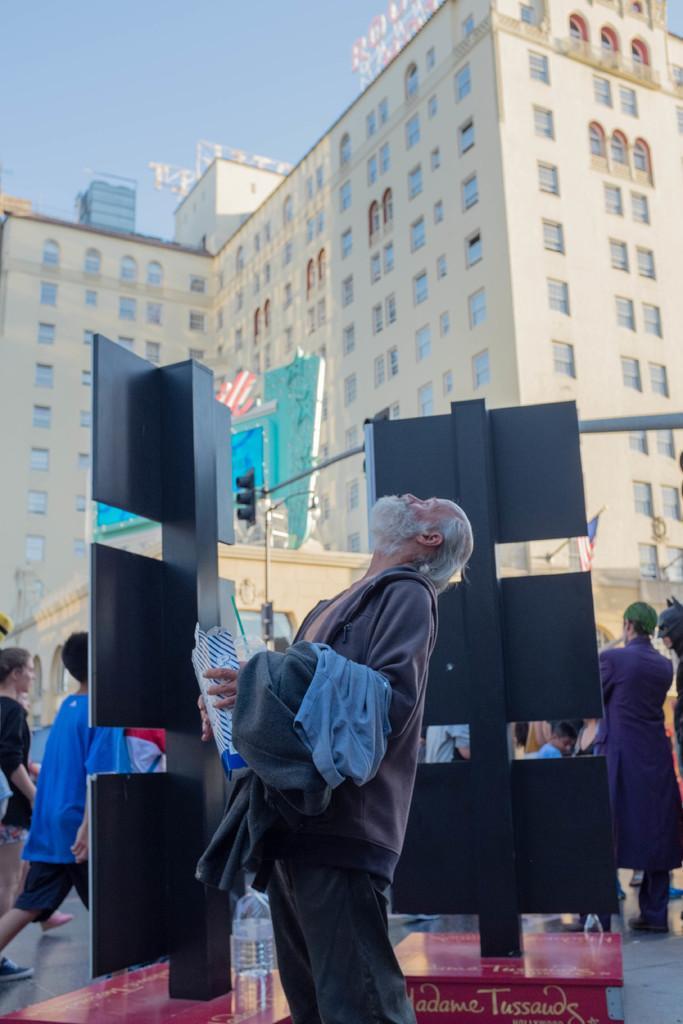Can you describe this image briefly? In this picture, we can see a man is holding an object and standing on the path. Behind the man there are poles with boards and traffic signals and there are a group of people some are sitting and some are standing on the path and at the background there are buildings and a sky. 